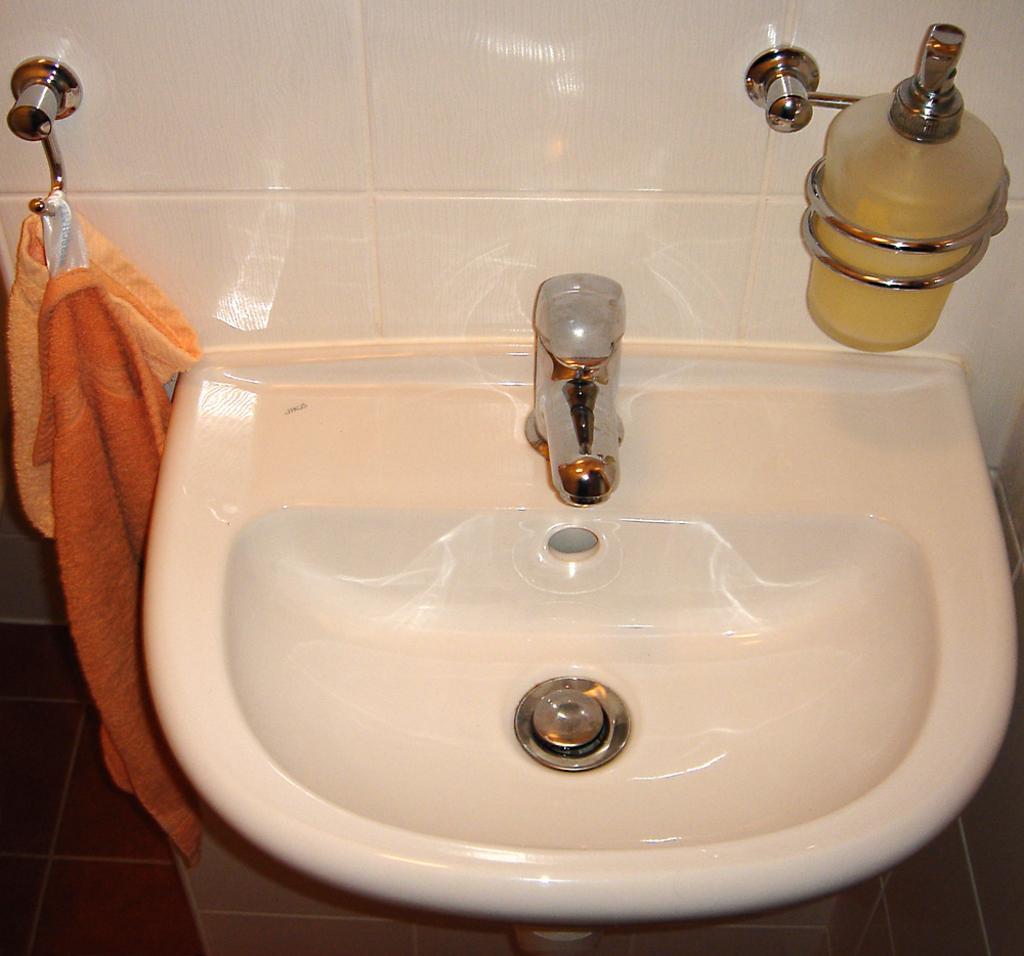How would you summarize this image in a sentence or two? In the image there is white color sink and white color tiles and there is a tap on the sink and wash cloth is hanged to the hanger. 